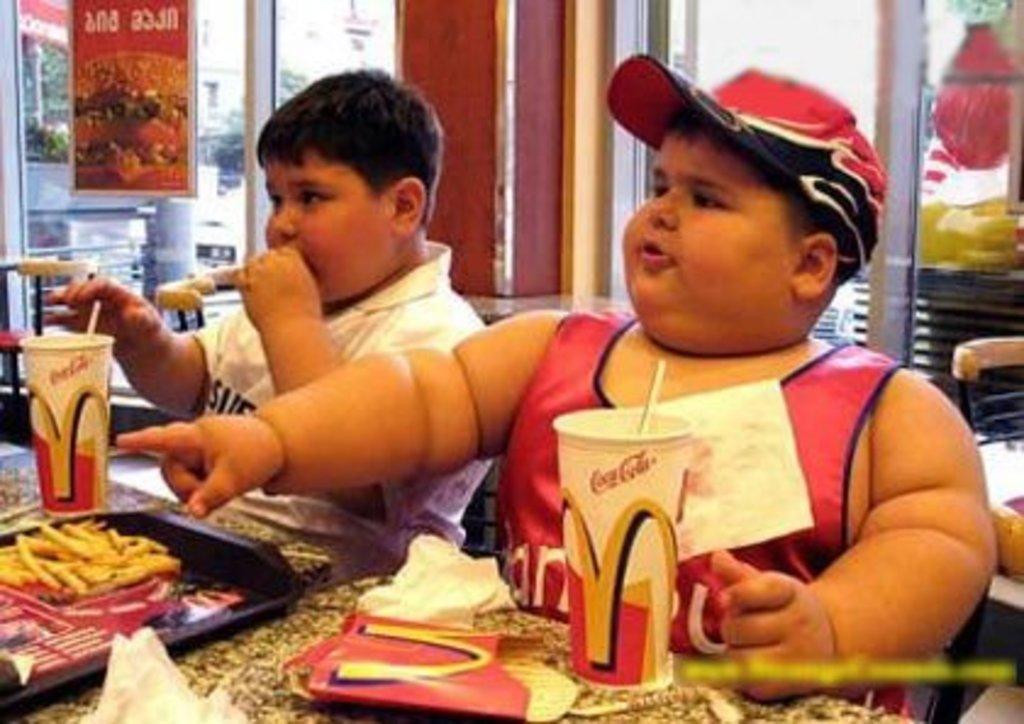Can you describe this image briefly? In the center of the image we can see two boys are sitting and a boy is eating, in-front of them we can see a table. On the table we can see a tray which contains food, cups with straws. In the background of the image we can see the wall, glass doors, a poster on the door and the floor. 